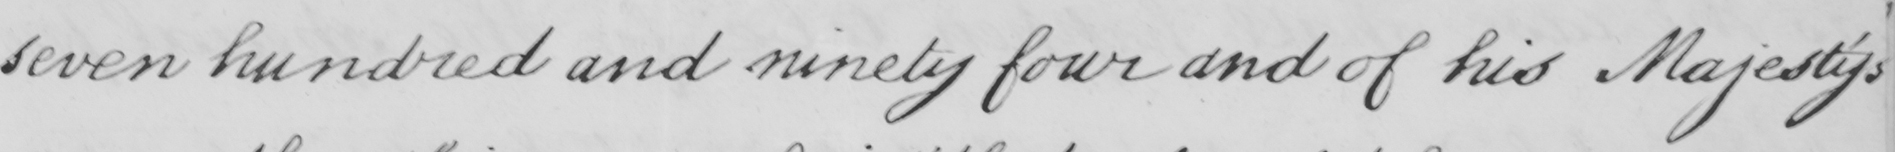Can you tell me what this handwritten text says? seven hundred and ninety four and of his Majesty ' s 